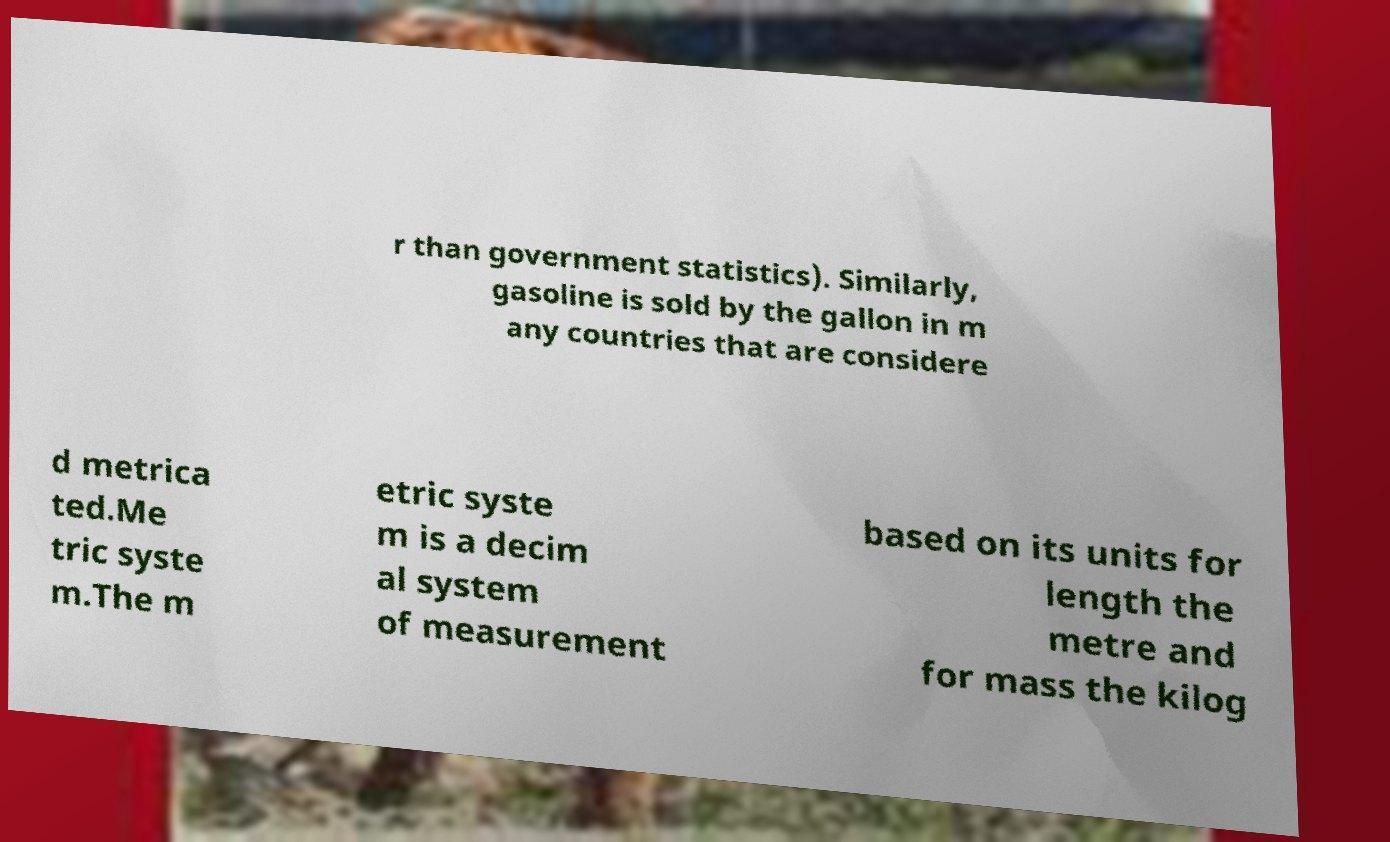Could you extract and type out the text from this image? r than government statistics). Similarly, gasoline is sold by the gallon in m any countries that are considere d metrica ted.Me tric syste m.The m etric syste m is a decim al system of measurement based on its units for length the metre and for mass the kilog 